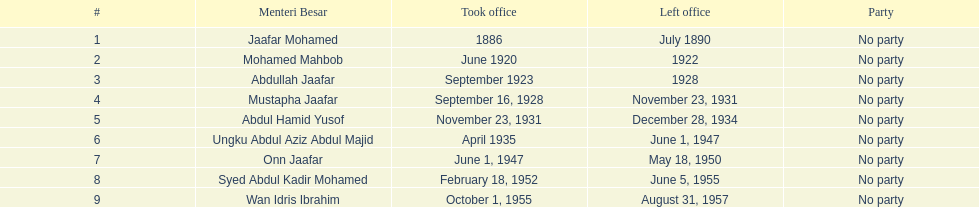Help me parse the entirety of this table. {'header': ['#', 'Menteri Besar', 'Took office', 'Left office', 'Party'], 'rows': [['1', 'Jaafar Mohamed', '1886', 'July 1890', 'No party'], ['2', 'Mohamed Mahbob', 'June 1920', '1922', 'No party'], ['3', 'Abdullah Jaafar', 'September 1923', '1928', 'No party'], ['4', 'Mustapha Jaafar', 'September 16, 1928', 'November 23, 1931', 'No party'], ['5', 'Abdul Hamid Yusof', 'November 23, 1931', 'December 28, 1934', 'No party'], ['6', 'Ungku Abdul Aziz Abdul Majid', 'April 1935', 'June 1, 1947', 'No party'], ['7', 'Onn Jaafar', 'June 1, 1947', 'May 18, 1950', 'No party'], ['8', 'Syed Abdul Kadir Mohamed', 'February 18, 1952', 'June 5, 1955', 'No party'], ['9', 'Wan Idris Ibrahim', 'October 1, 1955', 'August 31, 1957', 'No party']]} Who is listed below onn jaafar? Syed Abdul Kadir Mohamed. 